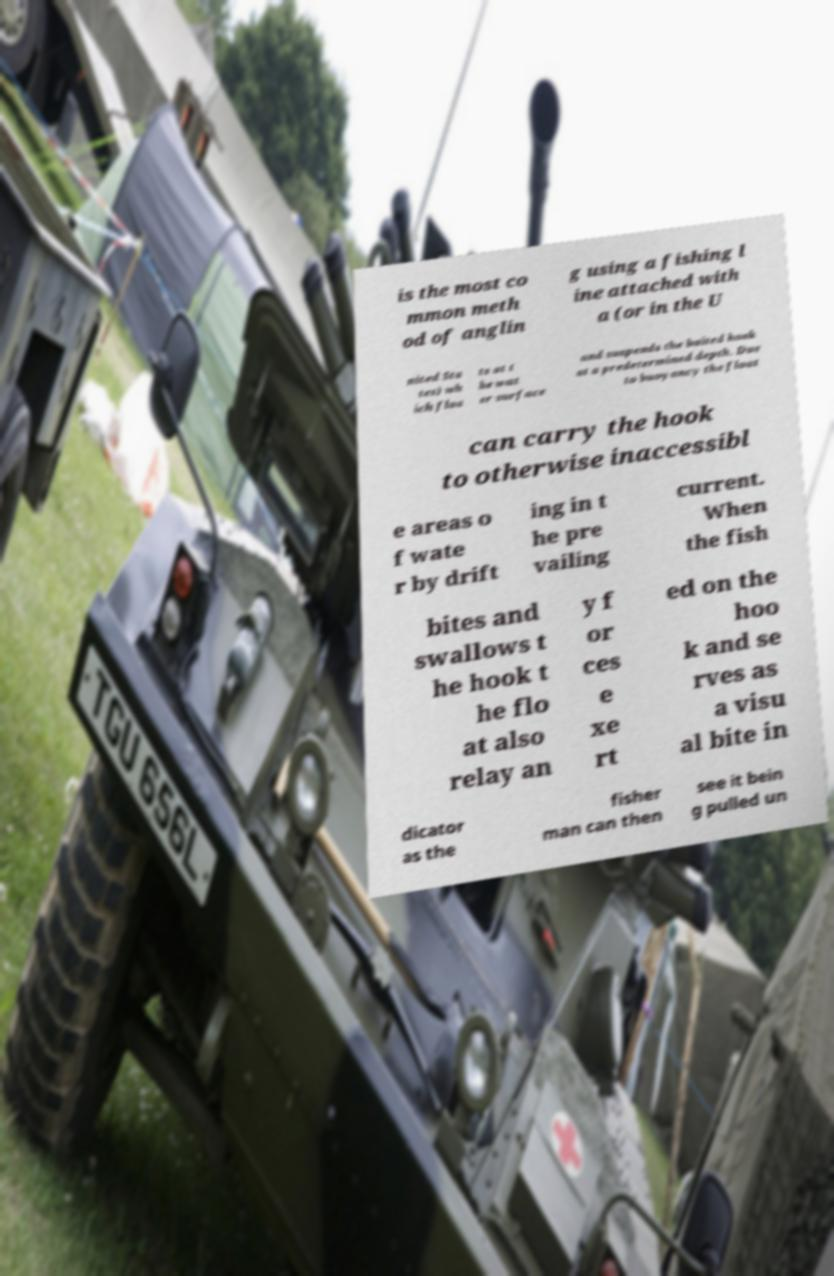Please identify and transcribe the text found in this image. is the most co mmon meth od of anglin g using a fishing l ine attached with a (or in the U nited Sta tes) wh ich floa ts at t he wat er surface and suspends the baited hook at a predetermined depth. Due to buoyancy the float can carry the hook to otherwise inaccessibl e areas o f wate r by drift ing in t he pre vailing current. When the fish bites and swallows t he hook t he flo at also relay an y f or ces e xe rt ed on the hoo k and se rves as a visu al bite in dicator as the fisher man can then see it bein g pulled un 